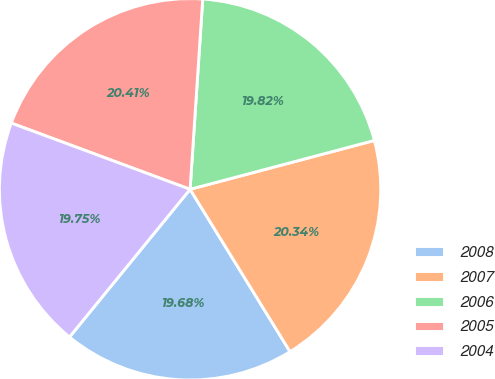Convert chart to OTSL. <chart><loc_0><loc_0><loc_500><loc_500><pie_chart><fcel>2008<fcel>2007<fcel>2006<fcel>2005<fcel>2004<nl><fcel>19.68%<fcel>20.34%<fcel>19.82%<fcel>20.41%<fcel>19.75%<nl></chart> 